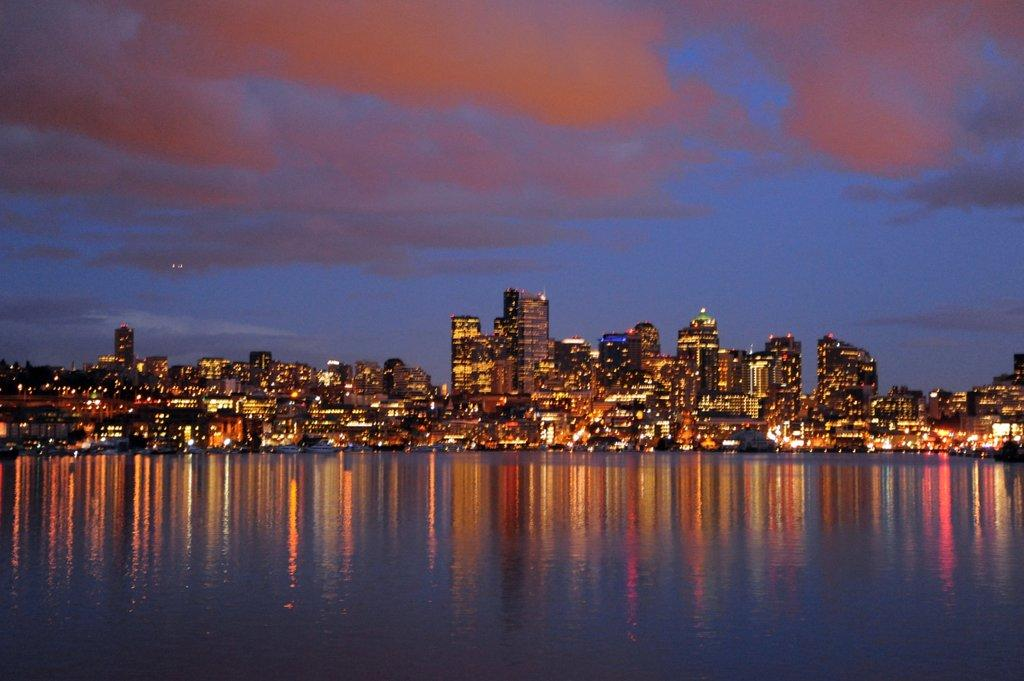What is the main element in the image? There is water in the image. What structures are located near the water? There are buildings with lights beside the water. What can be seen in the background of the image? The sky is visible in the background of the image. What type of glove is being used to tell a joke in the image? There is no glove or joke present in the image. 